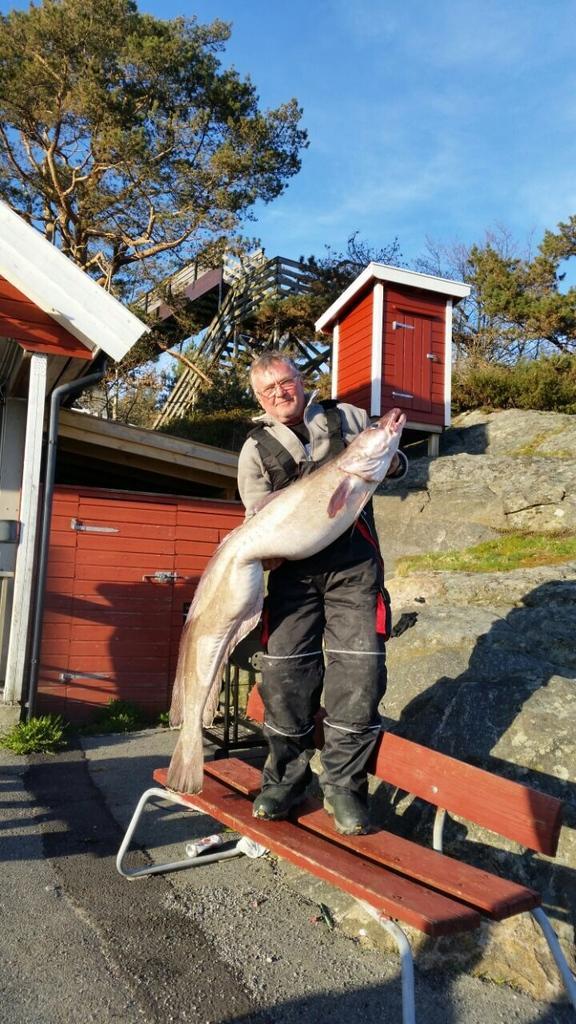Please provide a concise description of this image. In the given image we can see a man standing on a bench. He is catching fish in his hand. This is house, tree and sky which is in blue color. 